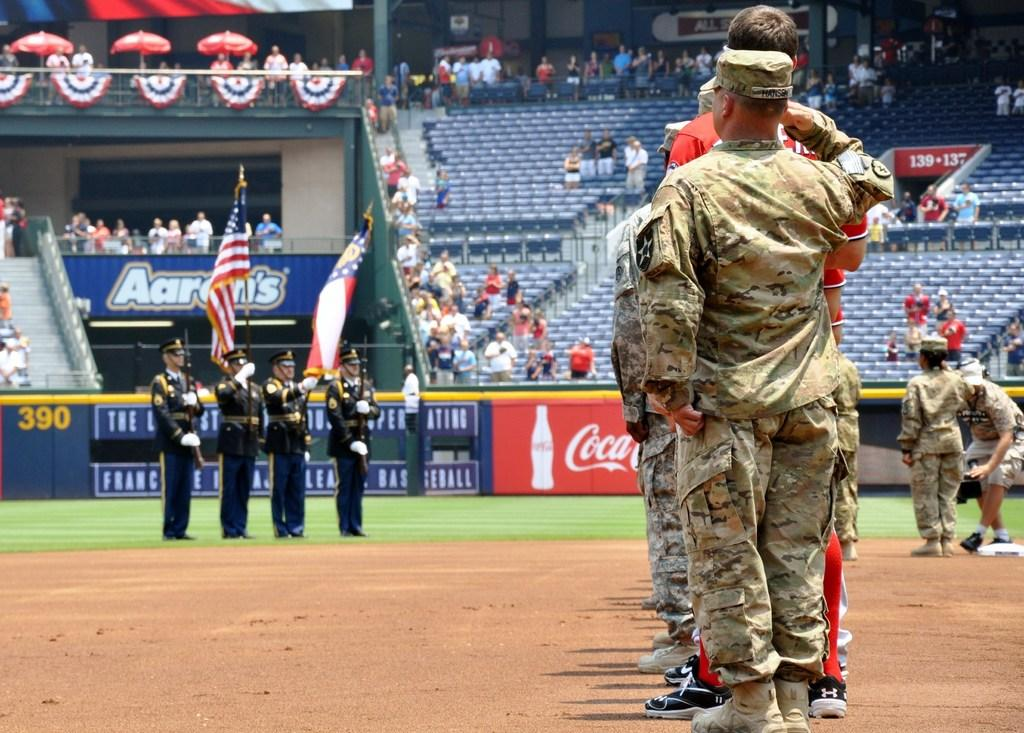<image>
Share a concise interpretation of the image provided. Soldiers and military men are on a baseball fielld an there is a coca cola sign displayed. 